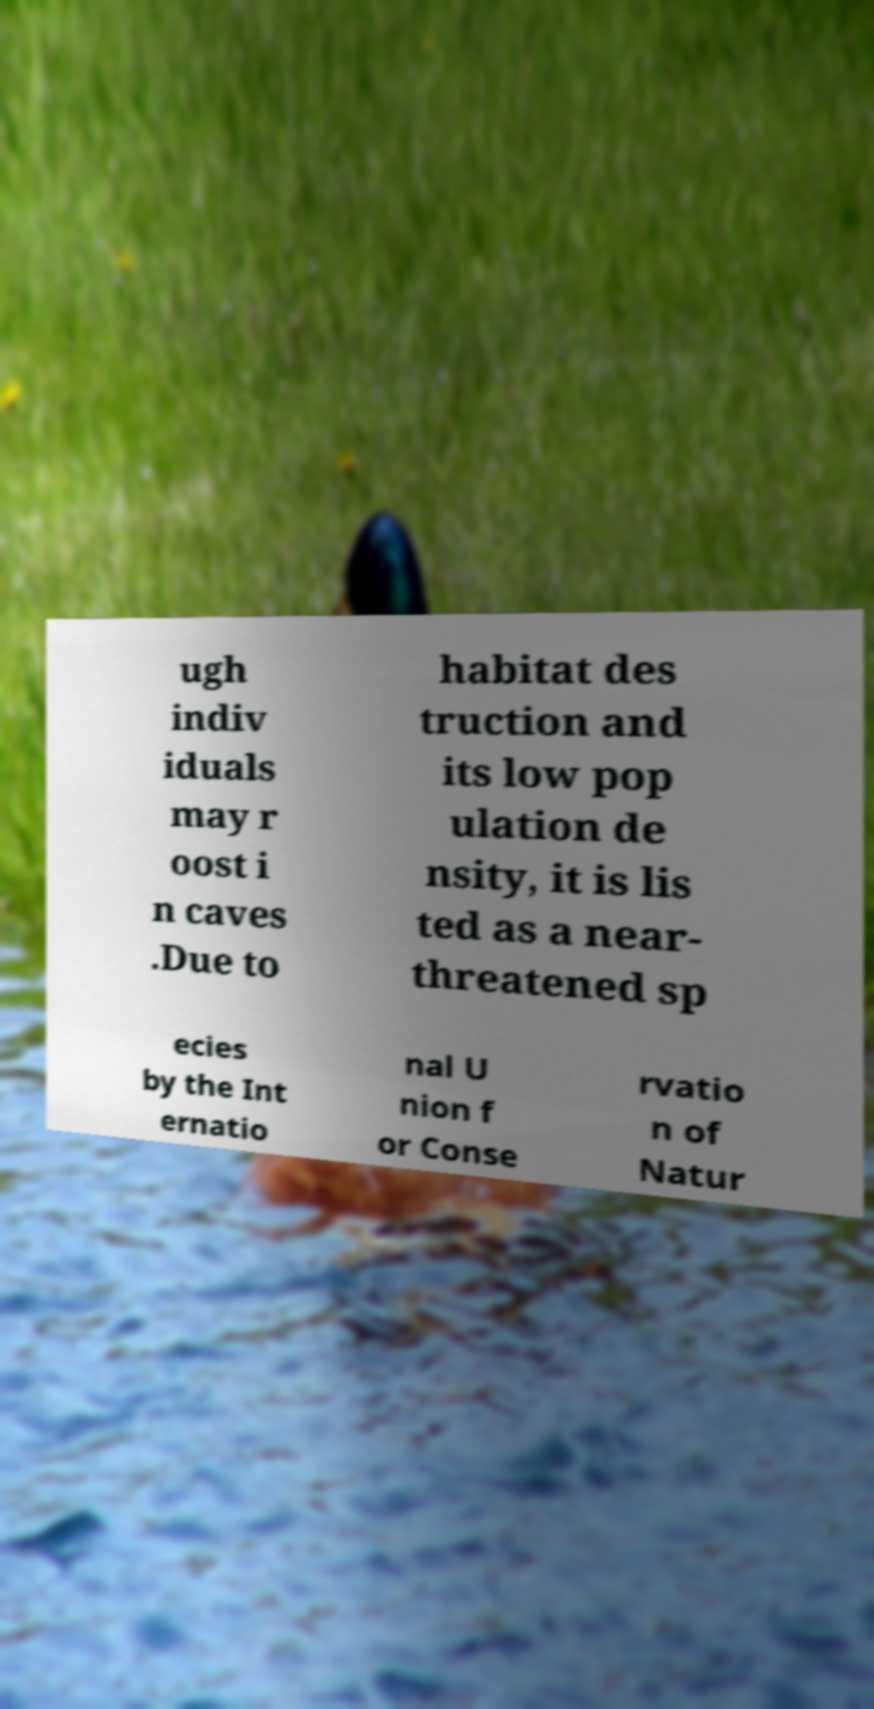There's text embedded in this image that I need extracted. Can you transcribe it verbatim? ugh indiv iduals may r oost i n caves .Due to habitat des truction and its low pop ulation de nsity, it is lis ted as a near- threatened sp ecies by the Int ernatio nal U nion f or Conse rvatio n of Natur 